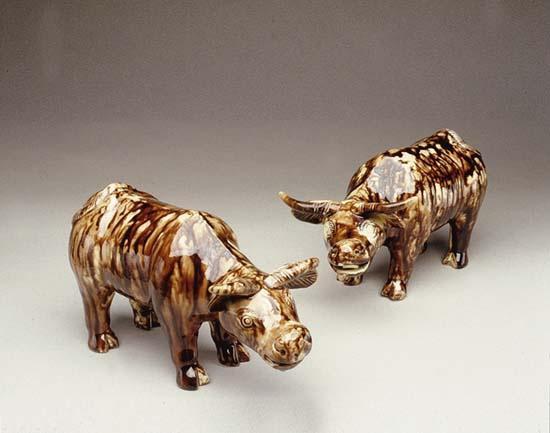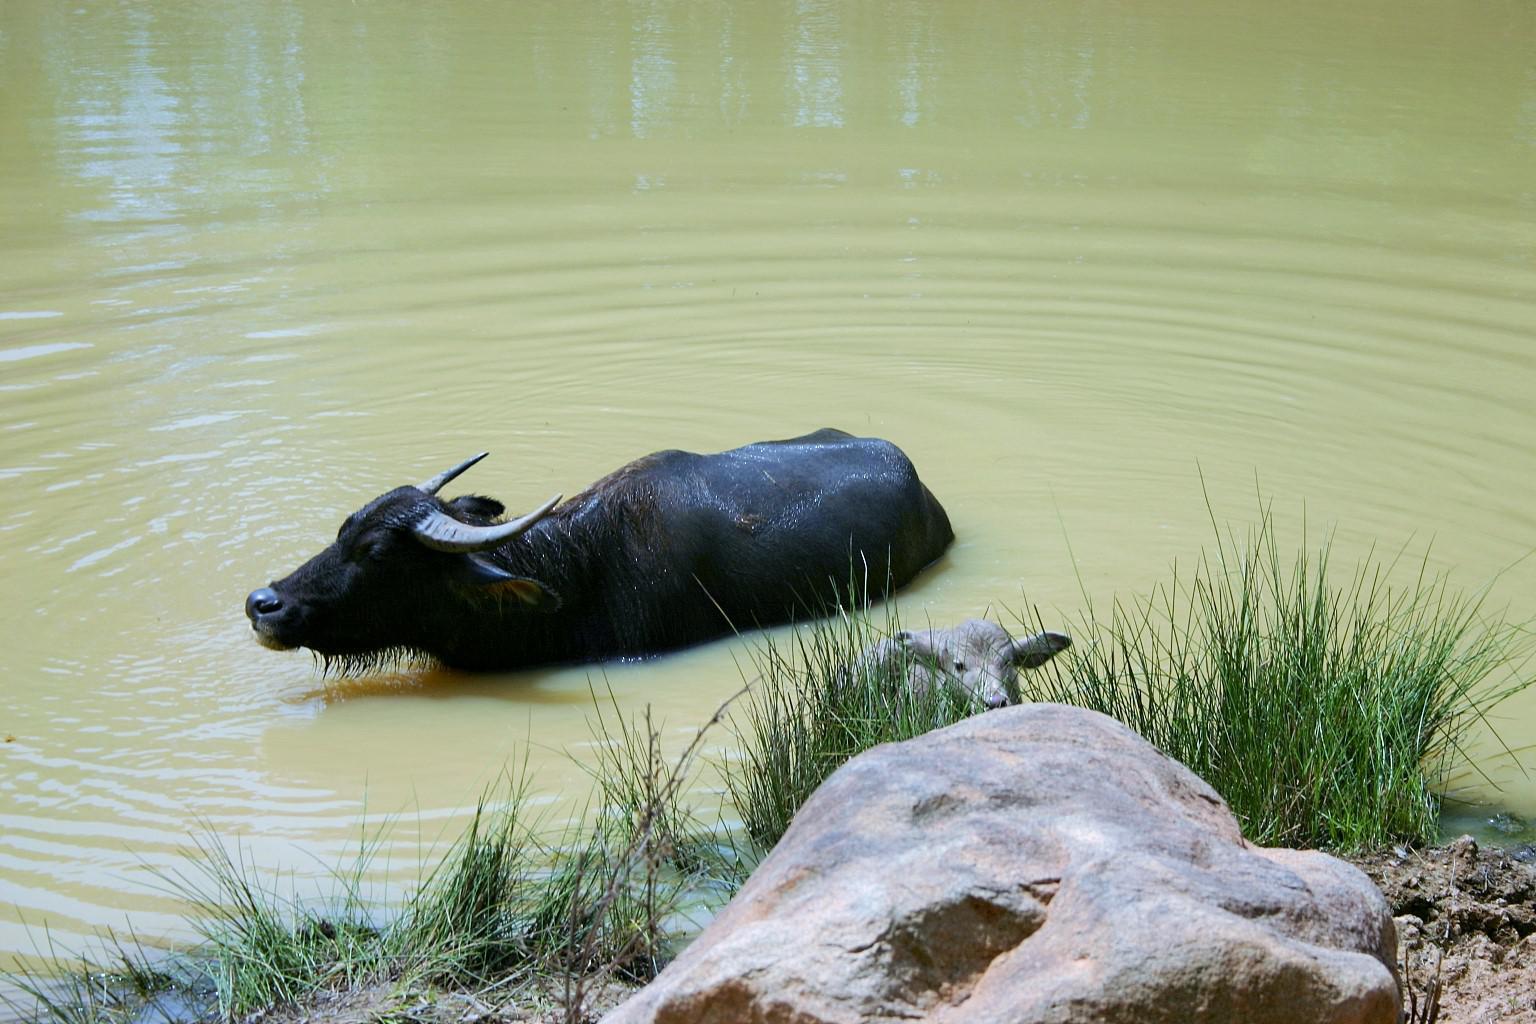The first image is the image on the left, the second image is the image on the right. For the images shown, is this caption "The left image contains a water buffalo with a bird standing on its back." true? Answer yes or no. No. The first image is the image on the left, the second image is the image on the right. Examine the images to the left and right. Is the description "The left image contains a sculpture of a water buffalo." accurate? Answer yes or no. Yes. 